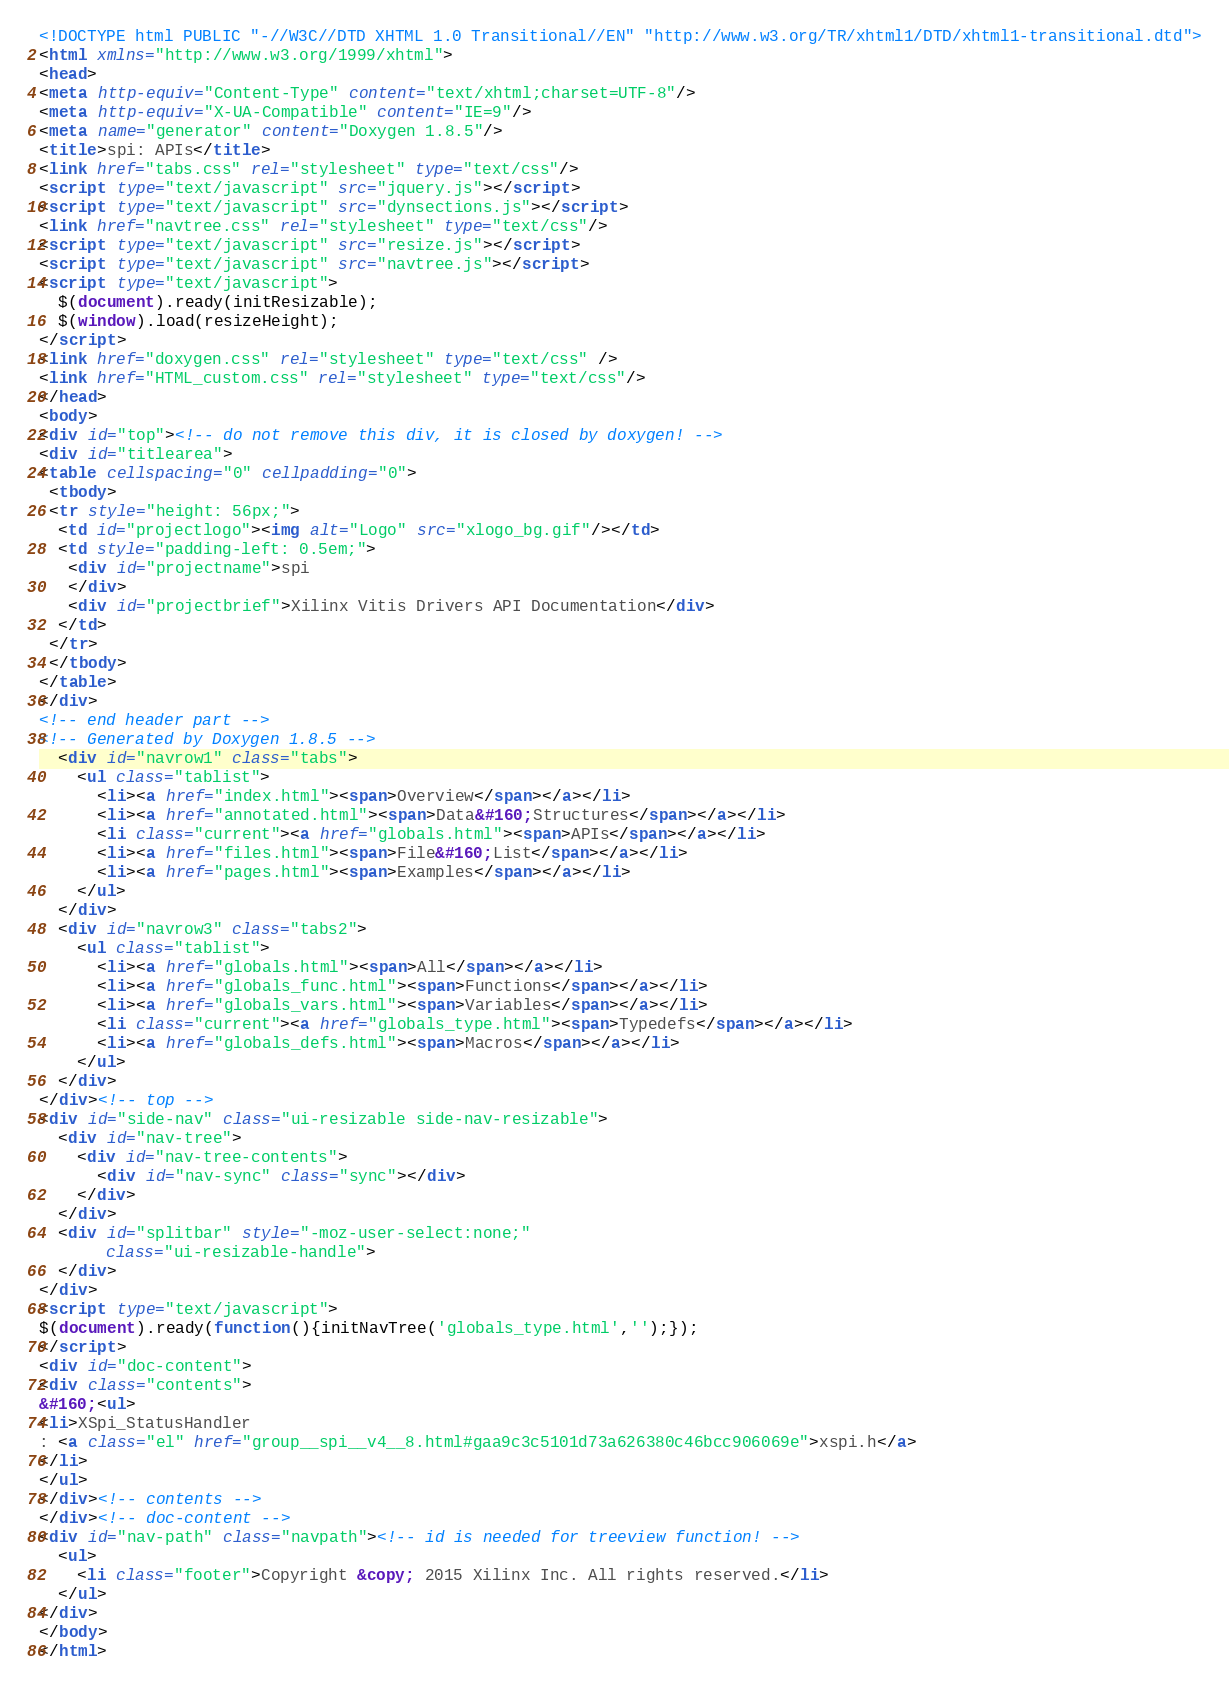<code> <loc_0><loc_0><loc_500><loc_500><_HTML_><!DOCTYPE html PUBLIC "-//W3C//DTD XHTML 1.0 Transitional//EN" "http://www.w3.org/TR/xhtml1/DTD/xhtml1-transitional.dtd">
<html xmlns="http://www.w3.org/1999/xhtml">
<head>
<meta http-equiv="Content-Type" content="text/xhtml;charset=UTF-8"/>
<meta http-equiv="X-UA-Compatible" content="IE=9"/>
<meta name="generator" content="Doxygen 1.8.5"/>
<title>spi: APIs</title>
<link href="tabs.css" rel="stylesheet" type="text/css"/>
<script type="text/javascript" src="jquery.js"></script>
<script type="text/javascript" src="dynsections.js"></script>
<link href="navtree.css" rel="stylesheet" type="text/css"/>
<script type="text/javascript" src="resize.js"></script>
<script type="text/javascript" src="navtree.js"></script>
<script type="text/javascript">
  $(document).ready(initResizable);
  $(window).load(resizeHeight);
</script>
<link href="doxygen.css" rel="stylesheet" type="text/css" />
<link href="HTML_custom.css" rel="stylesheet" type="text/css"/>
</head>
<body>
<div id="top"><!-- do not remove this div, it is closed by doxygen! -->
<div id="titlearea">
<table cellspacing="0" cellpadding="0">
 <tbody>
 <tr style="height: 56px;">
  <td id="projectlogo"><img alt="Logo" src="xlogo_bg.gif"/></td>
  <td style="padding-left: 0.5em;">
   <div id="projectname">spi
   </div>
   <div id="projectbrief">Xilinx Vitis Drivers API Documentation</div>
  </td>
 </tr>
 </tbody>
</table>
</div>
<!-- end header part -->
<!-- Generated by Doxygen 1.8.5 -->
  <div id="navrow1" class="tabs">
    <ul class="tablist">
      <li><a href="index.html"><span>Overview</span></a></li>
      <li><a href="annotated.html"><span>Data&#160;Structures</span></a></li>
      <li class="current"><a href="globals.html"><span>APIs</span></a></li>
      <li><a href="files.html"><span>File&#160;List</span></a></li>
      <li><a href="pages.html"><span>Examples</span></a></li>
    </ul>
  </div>
  <div id="navrow3" class="tabs2">
    <ul class="tablist">
      <li><a href="globals.html"><span>All</span></a></li>
      <li><a href="globals_func.html"><span>Functions</span></a></li>
      <li><a href="globals_vars.html"><span>Variables</span></a></li>
      <li class="current"><a href="globals_type.html"><span>Typedefs</span></a></li>
      <li><a href="globals_defs.html"><span>Macros</span></a></li>
    </ul>
  </div>
</div><!-- top -->
<div id="side-nav" class="ui-resizable side-nav-resizable">
  <div id="nav-tree">
    <div id="nav-tree-contents">
      <div id="nav-sync" class="sync"></div>
    </div>
  </div>
  <div id="splitbar" style="-moz-user-select:none;" 
       class="ui-resizable-handle">
  </div>
</div>
<script type="text/javascript">
$(document).ready(function(){initNavTree('globals_type.html','');});
</script>
<div id="doc-content">
<div class="contents">
&#160;<ul>
<li>XSpi_StatusHandler
: <a class="el" href="group__spi__v4__8.html#gaa9c3c5101d73a626380c46bcc906069e">xspi.h</a>
</li>
</ul>
</div><!-- contents -->
</div><!-- doc-content -->
<div id="nav-path" class="navpath"><!-- id is needed for treeview function! -->
  <ul>
    <li class="footer">Copyright &copy; 2015 Xilinx Inc. All rights reserved.</li>
  </ul>
</div>
</body>
</html>
</code> 